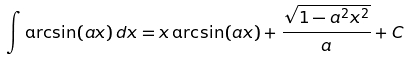<formula> <loc_0><loc_0><loc_500><loc_500>\int \arcsin ( a x ) \, d x = x \arcsin ( a x ) + { \frac { \sqrt { 1 - a ^ { 2 } x ^ { 2 } } } { a } } + C</formula> 